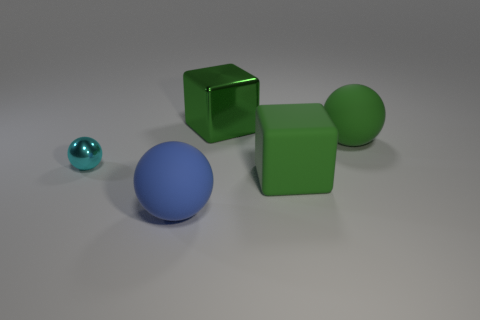Are there more small spheres that are behind the tiny sphere than spheres that are in front of the blue rubber sphere?
Keep it short and to the point. No. There is a thing that is both behind the large blue rubber thing and in front of the cyan object; what is its material?
Your answer should be very brief. Rubber. There is a small metallic object that is the same shape as the big blue object; what is its color?
Your answer should be very brief. Cyan. The cyan shiny sphere has what size?
Provide a short and direct response. Small. There is a metal thing behind the rubber sphere that is behind the cyan thing; what color is it?
Provide a succinct answer. Green. How many balls are both to the left of the blue rubber thing and to the right of the big blue object?
Offer a very short reply. 0. Are there more red balls than blue balls?
Make the answer very short. No. What is the material of the blue sphere?
Your answer should be very brief. Rubber. What number of green objects are behind the large block in front of the metallic sphere?
Your answer should be very brief. 2. There is a big shiny object; does it have the same color as the big rubber thing that is behind the cyan metal object?
Provide a short and direct response. Yes. 